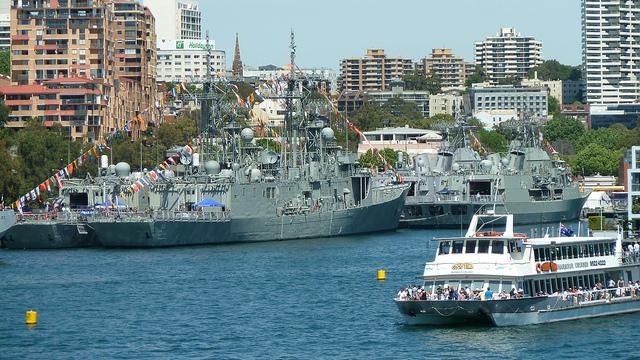What type of boat are the boats in this scene?
Write a very short answer. Ferry. What kind of ships have the bright triangle banners on them?
Give a very brief answer. Battleships. Is this a city?
Concise answer only. Yes. How many boats are in the water?
Keep it brief. 7. 